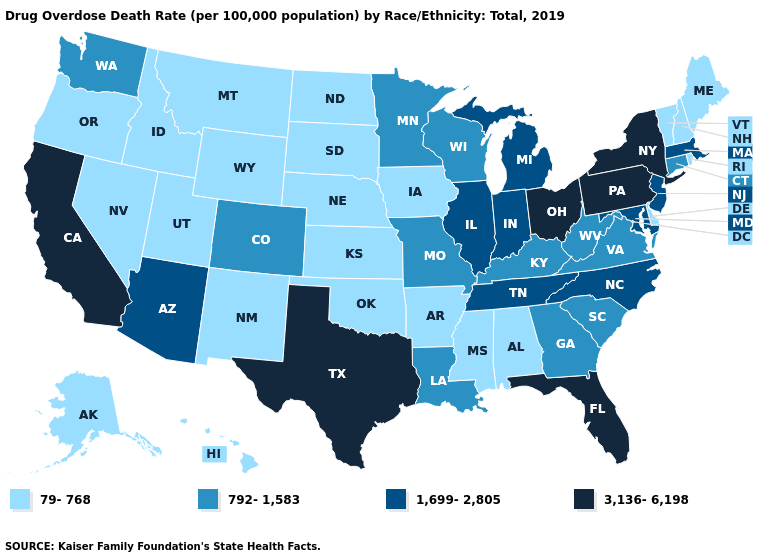Name the states that have a value in the range 79-768?
Be succinct. Alabama, Alaska, Arkansas, Delaware, Hawaii, Idaho, Iowa, Kansas, Maine, Mississippi, Montana, Nebraska, Nevada, New Hampshire, New Mexico, North Dakota, Oklahoma, Oregon, Rhode Island, South Dakota, Utah, Vermont, Wyoming. Does Missouri have a lower value than Idaho?
Concise answer only. No. What is the highest value in the USA?
Write a very short answer. 3,136-6,198. Name the states that have a value in the range 792-1,583?
Give a very brief answer. Colorado, Connecticut, Georgia, Kentucky, Louisiana, Minnesota, Missouri, South Carolina, Virginia, Washington, West Virginia, Wisconsin. Name the states that have a value in the range 792-1,583?
Write a very short answer. Colorado, Connecticut, Georgia, Kentucky, Louisiana, Minnesota, Missouri, South Carolina, Virginia, Washington, West Virginia, Wisconsin. Name the states that have a value in the range 792-1,583?
Write a very short answer. Colorado, Connecticut, Georgia, Kentucky, Louisiana, Minnesota, Missouri, South Carolina, Virginia, Washington, West Virginia, Wisconsin. What is the value of Georgia?
Keep it brief. 792-1,583. Does South Carolina have the lowest value in the South?
Quick response, please. No. Does New Jersey have the lowest value in the Northeast?
Keep it brief. No. Name the states that have a value in the range 3,136-6,198?
Keep it brief. California, Florida, New York, Ohio, Pennsylvania, Texas. Name the states that have a value in the range 3,136-6,198?
Write a very short answer. California, Florida, New York, Ohio, Pennsylvania, Texas. What is the value of North Carolina?
Keep it brief. 1,699-2,805. Among the states that border Pennsylvania , which have the lowest value?
Answer briefly. Delaware. Does the map have missing data?
Concise answer only. No. Name the states that have a value in the range 3,136-6,198?
Be succinct. California, Florida, New York, Ohio, Pennsylvania, Texas. 